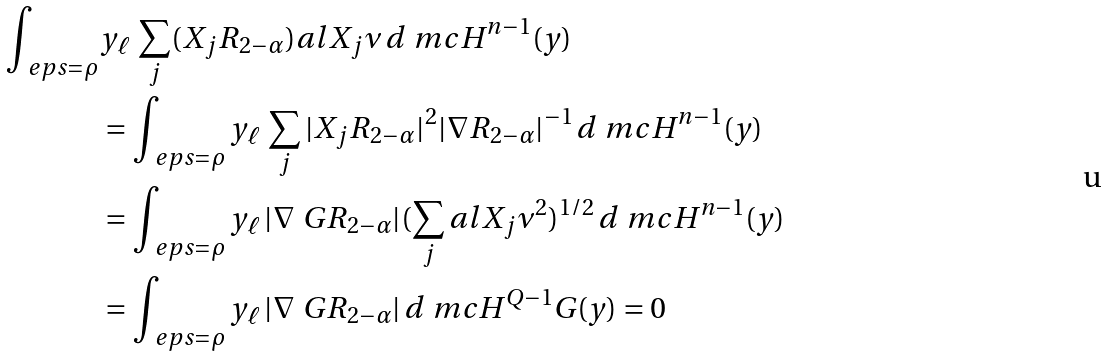Convert formula to latex. <formula><loc_0><loc_0><loc_500><loc_500>\int _ { \ e p s = \rho } & y _ { \ell } \, \sum _ { j } ( X _ { j } R _ { 2 - \alpha } ) a l { X _ { j } } { \nu } \, d \ m c H ^ { n - 1 } ( y ) \\ & = \int _ { \ e p s = \rho } y _ { \ell } \, \sum _ { j } | X _ { j } R _ { 2 - \alpha } | ^ { 2 } | \nabla R _ { 2 - \alpha } | ^ { - 1 } \, d \ m c H ^ { n - 1 } ( y ) \\ & = \int _ { \ e p s = \rho } y _ { \ell } \, | \nabla _ { \ } G R _ { 2 - \alpha } | ( \sum _ { j } a l { X _ { j } } { \nu } ^ { 2 } ) ^ { 1 / 2 } \, d \ m c H ^ { n - 1 } ( y ) \\ & = \int _ { \ e p s = \rho } y _ { \ell } \, | \nabla _ { \ } G R _ { 2 - \alpha } | \, d \ m c H ^ { Q - 1 } _ { \ } G ( y ) = 0</formula> 